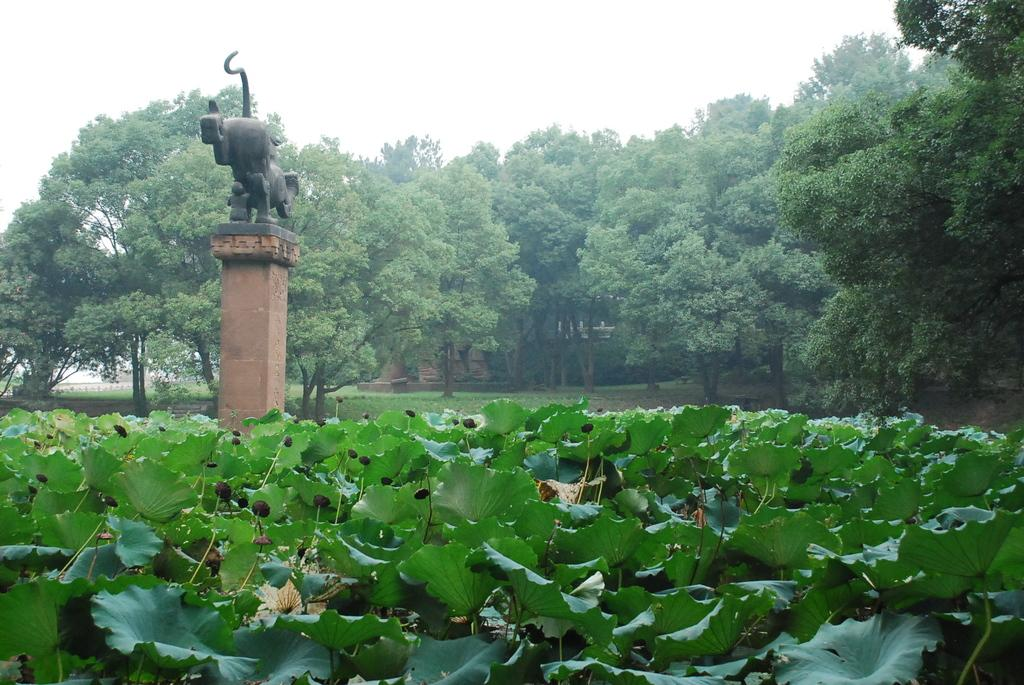What type of natural elements are present in the image? There are trees and plants in the image. What color are the trees and plants in the image? The trees and plants are in green color. What other object can be seen in the image besides the trees and plants? A: There is a statue in the image. What part of the natural environment is visible in the image? The sky is visible in the image. What color is the sky in the image? The sky is in white color. What type of game is being played by the zebra in the image? There is no zebra present in the image, so no game can be observed. What request is being made by the statue in the image? There is no request being made by the statue in the image, as statues are inanimate objects and cannot make requests. 